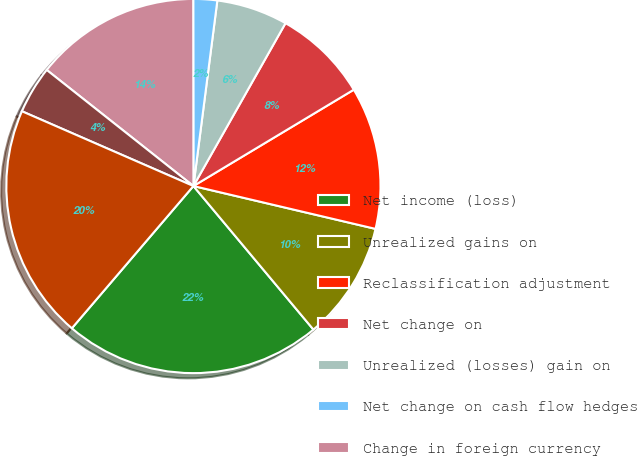Convert chart to OTSL. <chart><loc_0><loc_0><loc_500><loc_500><pie_chart><fcel>Net income (loss)<fcel>Unrealized gains on<fcel>Reclassification adjustment<fcel>Net change on<fcel>Unrealized (losses) gain on<fcel>Net change on cash flow hedges<fcel>Change in foreign currency<fcel>Other comprehensive (losses)<fcel>Comprehensive income (loss)<nl><fcel>22.34%<fcel>10.24%<fcel>12.29%<fcel>8.2%<fcel>6.15%<fcel>2.06%<fcel>14.33%<fcel>4.11%<fcel>20.29%<nl></chart> 